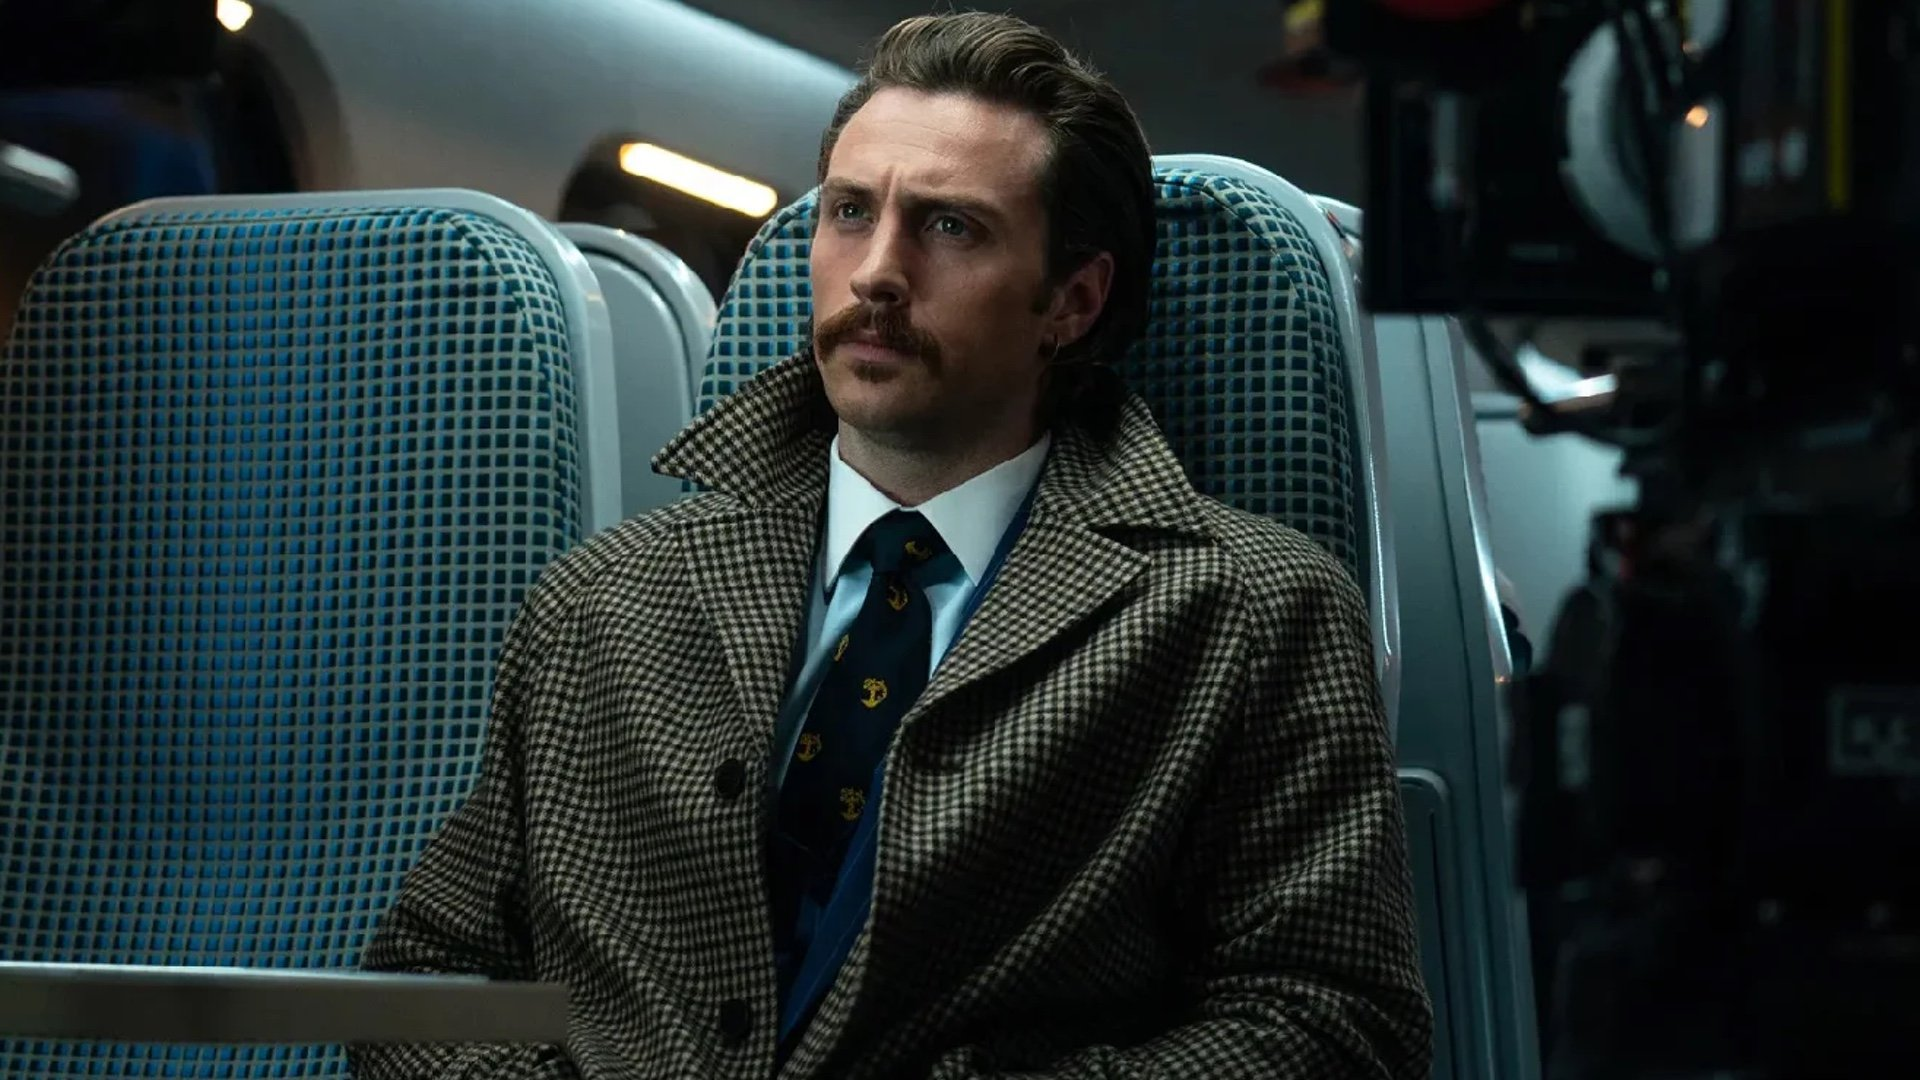What do you think is going on in this snapshot? In the image, actor Aaron Taylor Johnson is captured in character as Ray Marcus from the movie "Nocturnal Animals". He is seated in a train car, his gaze directed off to the side, embodying a serious expression. His attire consists of a brown houndstooth coat and a blue tie adorned with gold accents. The train car around him is furnished with blue seats, and a camera can be spotted in one corner. 